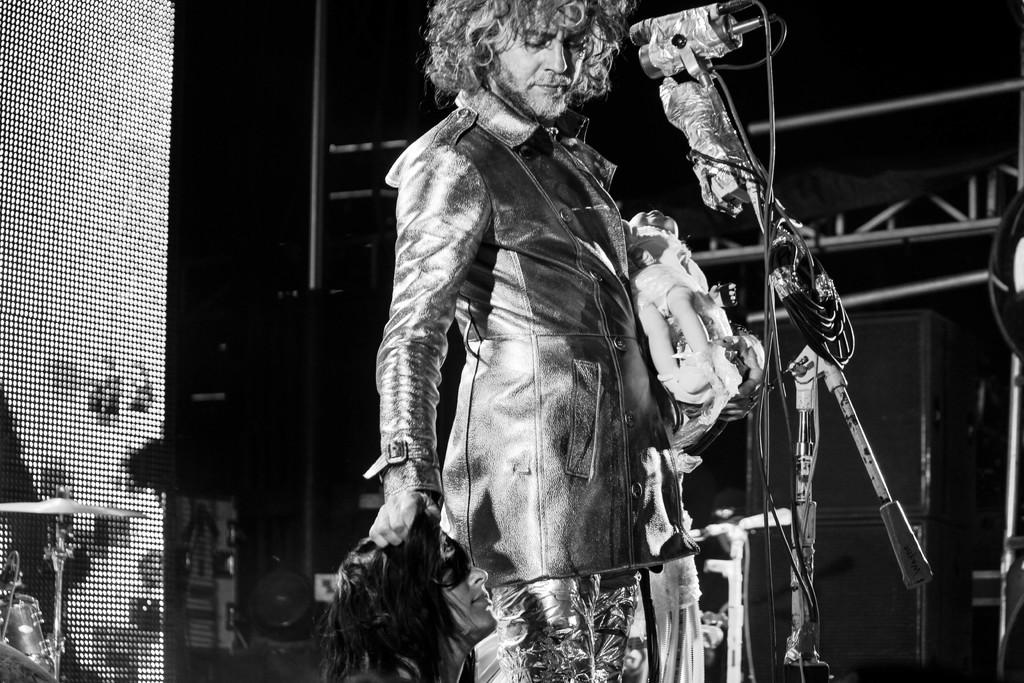What is the man in the image doing? The man is standing in front of microphones in the image. What is the color scheme of the image? The image is black and white in color. What can be seen on the left side of the image? There are musical instruments on the left side of the image. What type of cork can be seen in the image? There is no cork present in the image. Does the man in the image believe in the power of music? The image does not provide any information about the man's beliefs or opinions, so it cannot be determined from the image. 